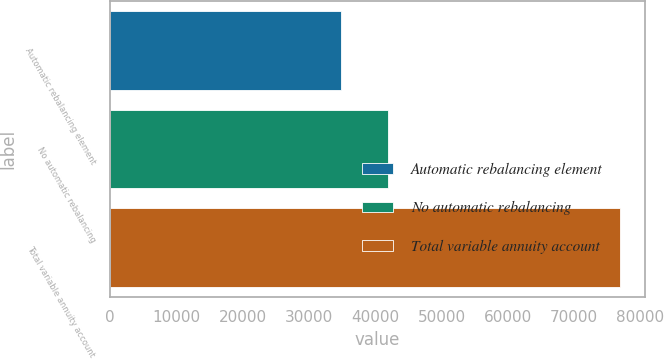<chart> <loc_0><loc_0><loc_500><loc_500><bar_chart><fcel>Automatic rebalancing element<fcel>No automatic rebalancing<fcel>Total variable annuity account<nl><fcel>34901<fcel>41975<fcel>76876<nl></chart> 